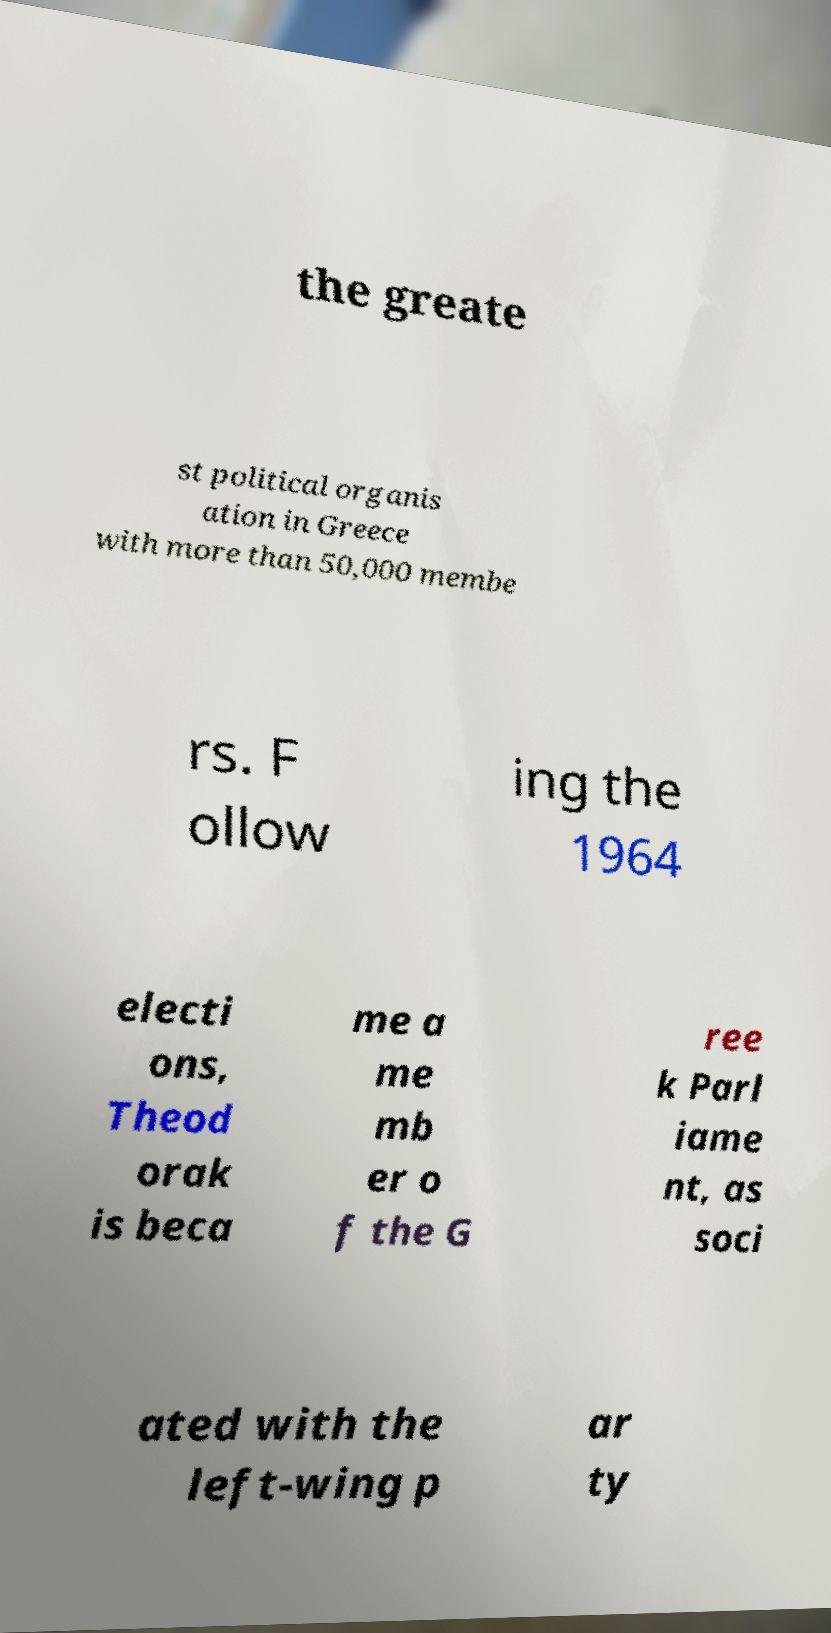Could you extract and type out the text from this image? the greate st political organis ation in Greece with more than 50,000 membe rs. F ollow ing the 1964 electi ons, Theod orak is beca me a me mb er o f the G ree k Parl iame nt, as soci ated with the left-wing p ar ty 